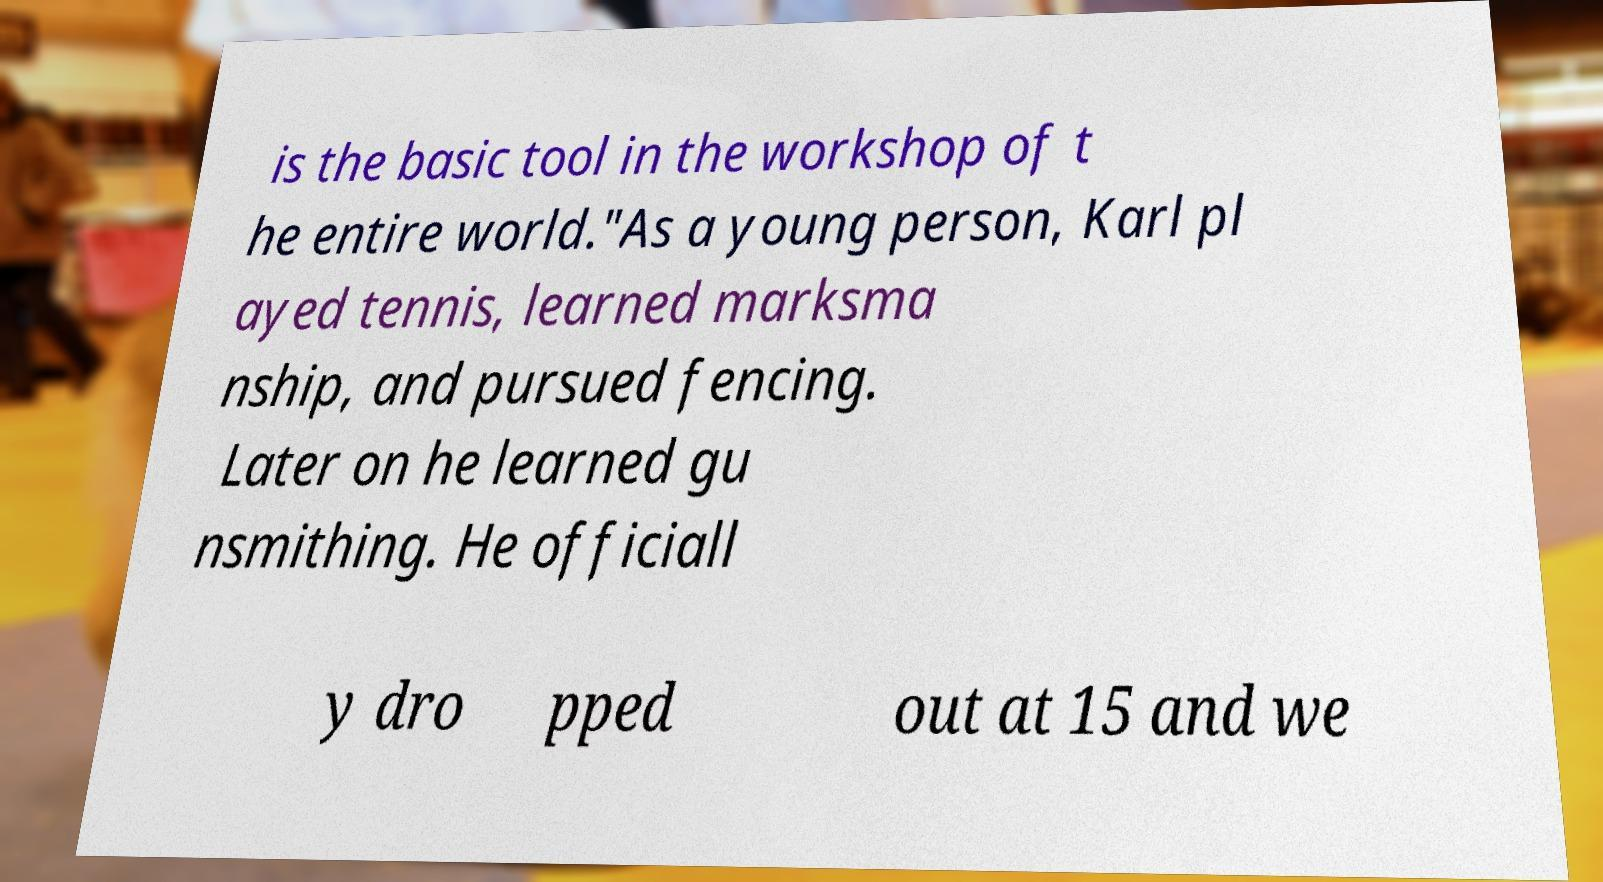What messages or text are displayed in this image? I need them in a readable, typed format. is the basic tool in the workshop of t he entire world."As a young person, Karl pl ayed tennis, learned marksma nship, and pursued fencing. Later on he learned gu nsmithing. He officiall y dro pped out at 15 and we 